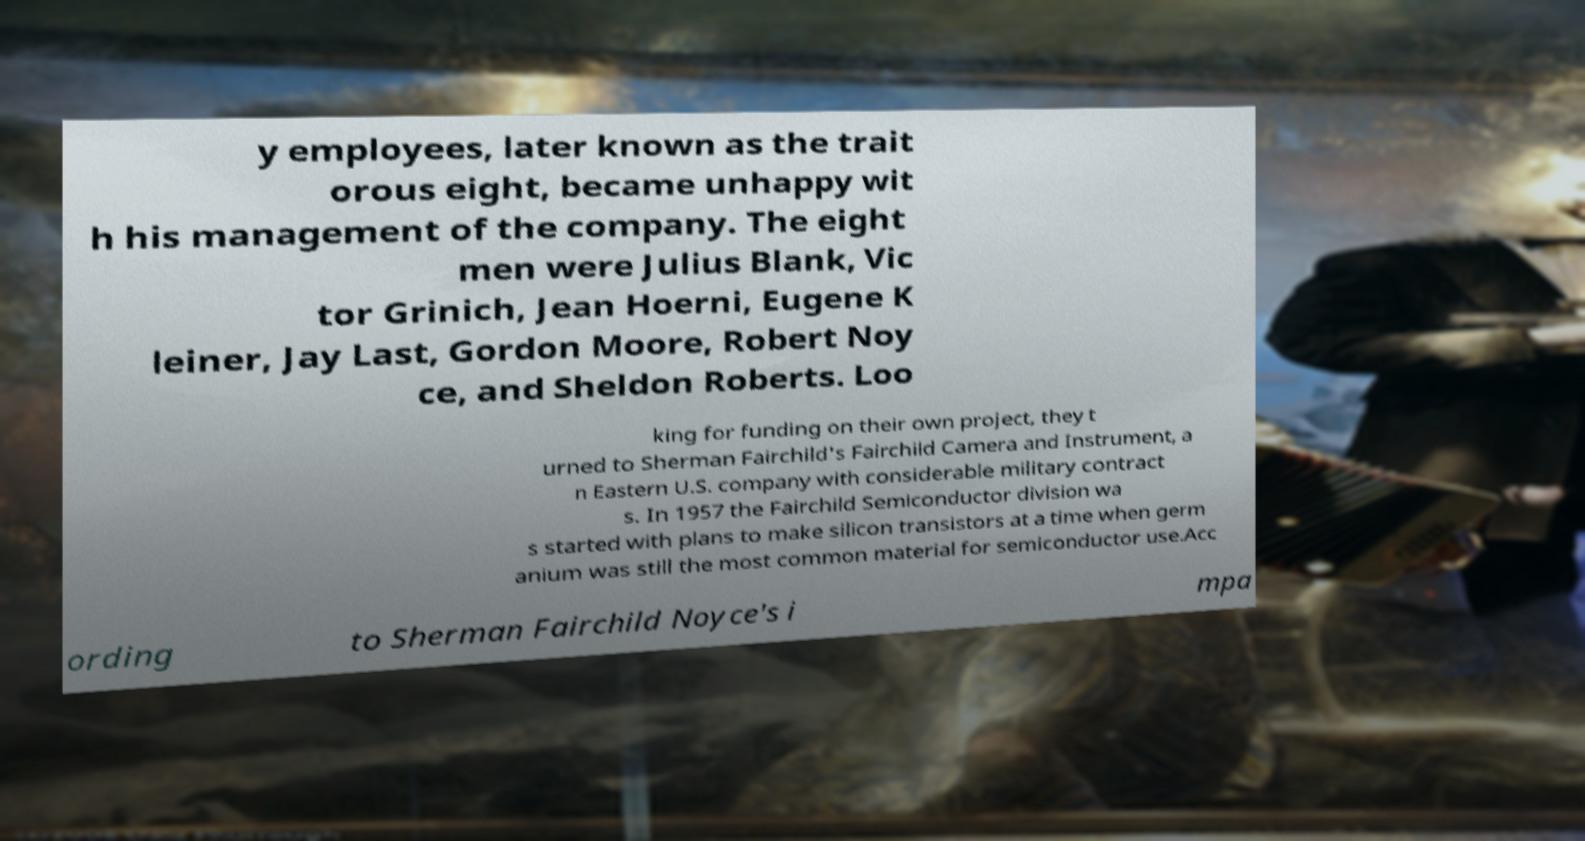Please identify and transcribe the text found in this image. y employees, later known as the trait orous eight, became unhappy wit h his management of the company. The eight men were Julius Blank, Vic tor Grinich, Jean Hoerni, Eugene K leiner, Jay Last, Gordon Moore, Robert Noy ce, and Sheldon Roberts. Loo king for funding on their own project, they t urned to Sherman Fairchild's Fairchild Camera and Instrument, a n Eastern U.S. company with considerable military contract s. In 1957 the Fairchild Semiconductor division wa s started with plans to make silicon transistors at a time when germ anium was still the most common material for semiconductor use.Acc ording to Sherman Fairchild Noyce's i mpa 